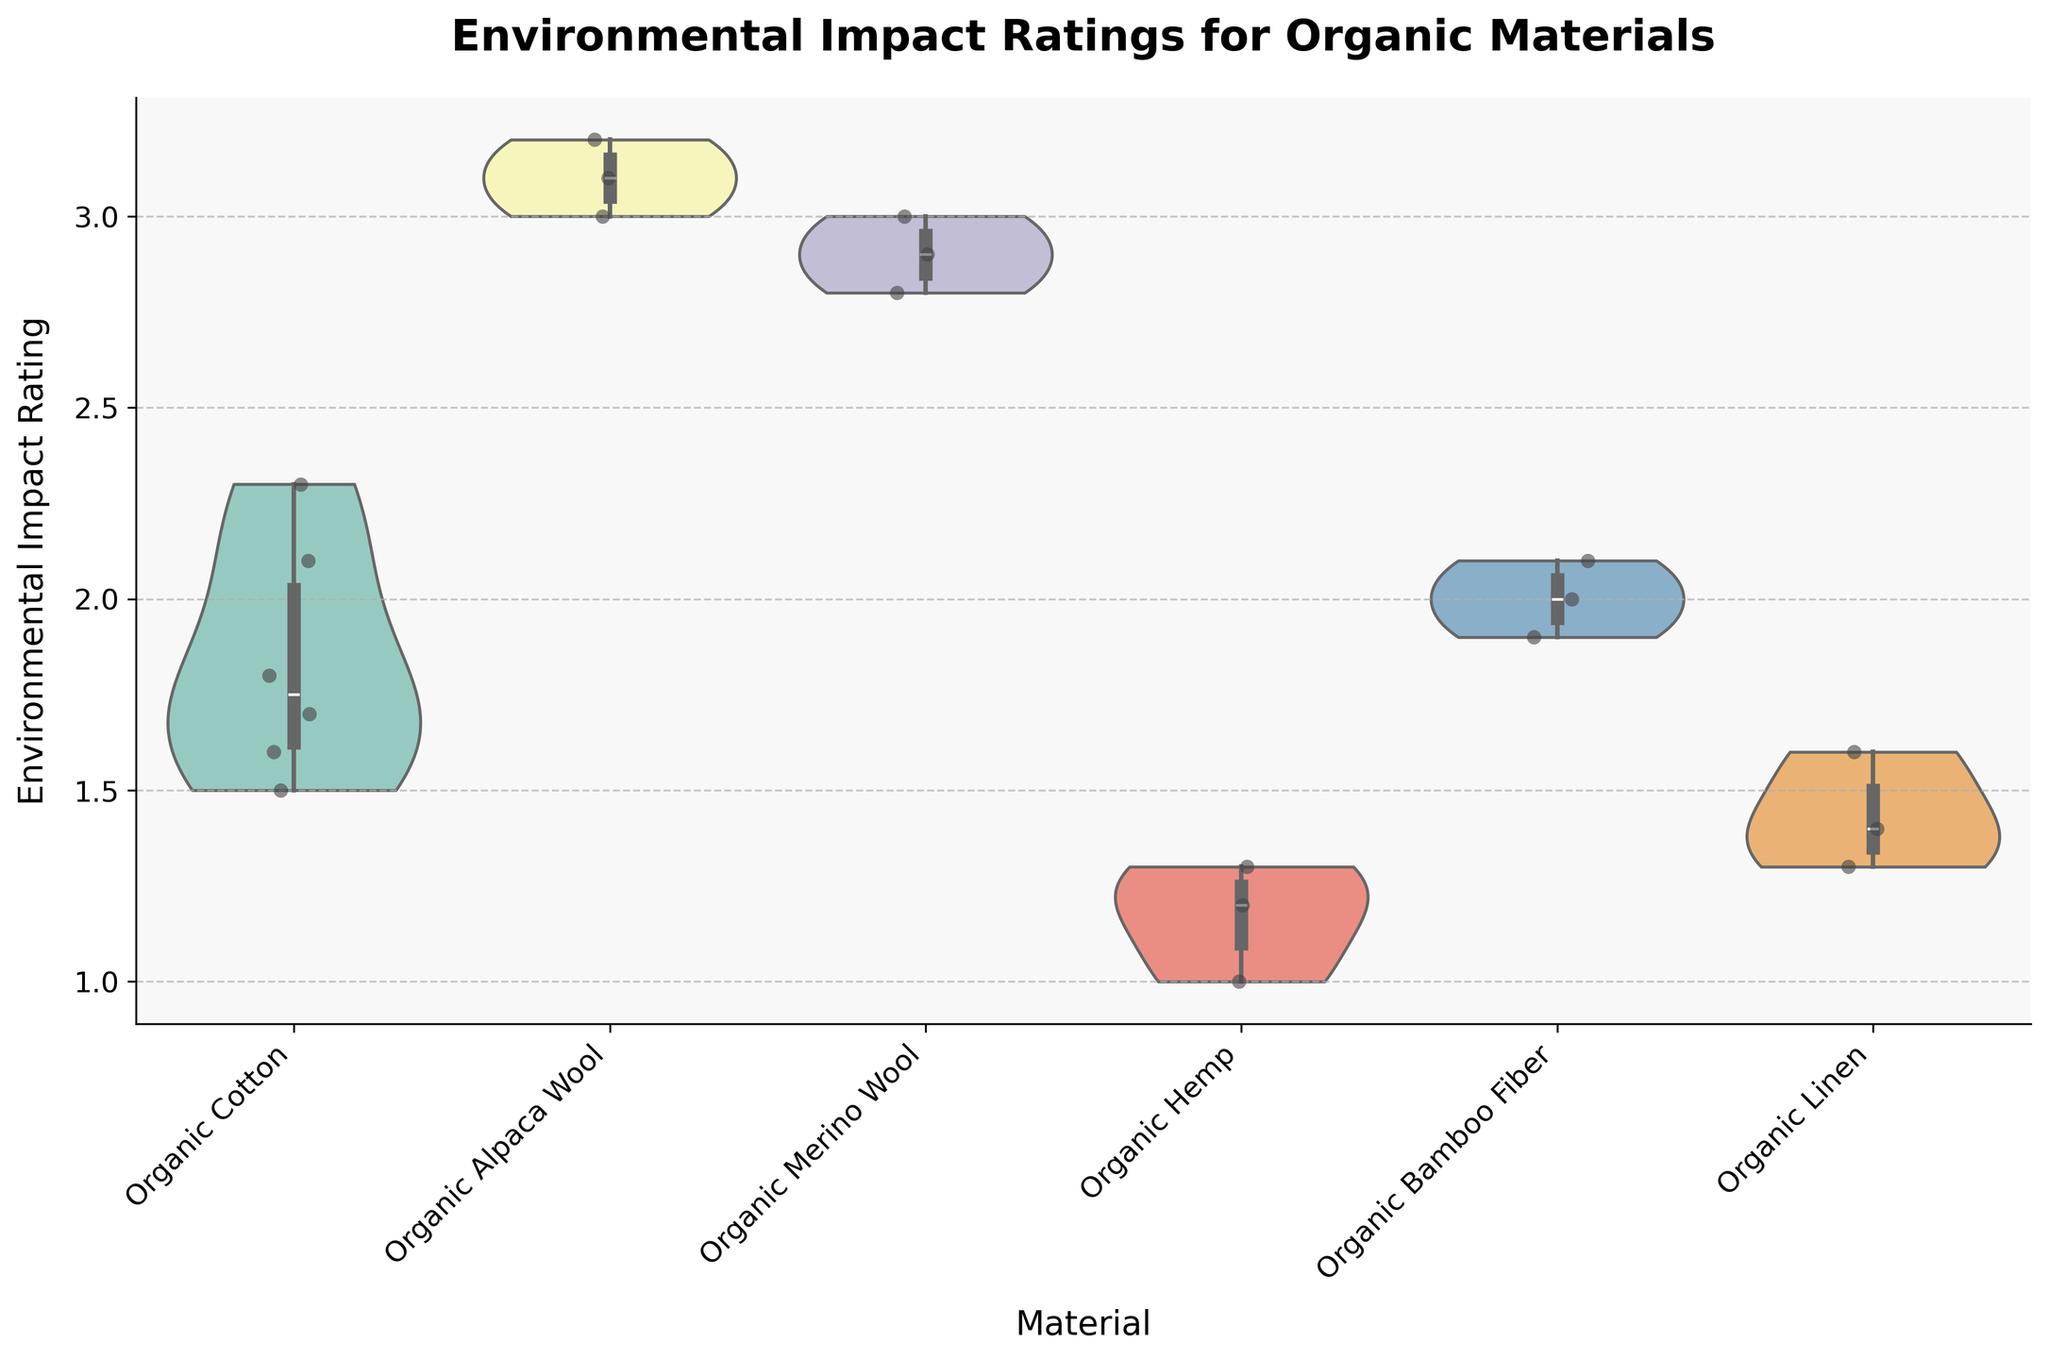What title is given to the figure? The title is usually found at the top of the figure. It's generally written in larger or bold text to distinguish it from other elements. Here, the title is "Environmental Impact Ratings for Organic Materials."
Answer: Environmental Impact Ratings for Organic Materials What is the range of the Environmental Impact Ratings shown on the y-axis? Observing the y-axis, it's clear that the Environmental Impact Ratings range from the minimum to maximum values displayed on this axis. Here, the range is from 1.0 to 3.5.
Answer: 1.0 to 3.5 Which material seems to have the highest median Environmental Impact Rating? A violin plot typically displays the median as part of the inner box. Looking at these boxes, the material with the box positioned highest on the y-axis corresponds to the highest median value. Here, Organic Alpaca Wool shows the highest median.
Answer: Organic Alpaca Wool How does the Environmental Impact Rating of Organic Bamboo Fiber compare to Organic Cotton? By comparing the widths and positions of the violins, we can see that Organic Cotton has a slightly higher spread and central tendency compared to Organic Bamboo Fiber, the latter showing lower Environmental Impact Ratings overall.
Answer: Organic Cotton is higher Which material sourced from the USA has the lowest Environmental Impact Ratings based on the plot? The points are jittered within each violin; observing the data points, Organic Hemp sourced from the USA has the lowest Environmental Impact Ratings. The points are clustered around the lower end of the y-axis.
Answer: Organic Hemp Are the Environmental Impact Ratings for Organic Alpaca Wool more or less variable than Organic Linen? The variability in a violin plot can be observed by the shape and spread of the violins. Organic Alpaca Wool has a wider violin, indicating higher variability compared to Organic Linen, which has a narrower spread.
Answer: More variable What can be inferred about the distribution of Environmental Impact Ratings for Organic Linen? The distribution for Organic Linen is represented by a relatively narrow violin, suggesting less variability. Most of the data points are also close together, indicating a more uniform rating distribution.
Answer: Less variable, more uniform distribution What is the median Environmental Impact Rating for Organic Merino Wool? From the plot, Organic Merino Wool's median is around the middle of the violin plot's inner box. Observing this, the median appears to be approximately 2.9.
Answer: 2.9 Which material has the closest median Environmental Impact Rating to Organic Bamboo Fiber? By comparing the median lines of all violins, Organic Cotton has a median close to that of Organic Bamboo Fiber, both around the lower end of the Environmental Impact Ratings.
Answer: Organic Cotton Are there any materials that show overlapping distributions in their Environmental Impact Ratings? Observing the violins, considerable overlap can be seen between Organic Cotton and Organic Bamboo Fiber, indicating similar distribution characteristics in their ratings.
Answer: Yes, Organic Cotton and Organic Bamboo Fiber 